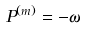<formula> <loc_0><loc_0><loc_500><loc_500>P ^ { ( m ) } = - \omega</formula> 